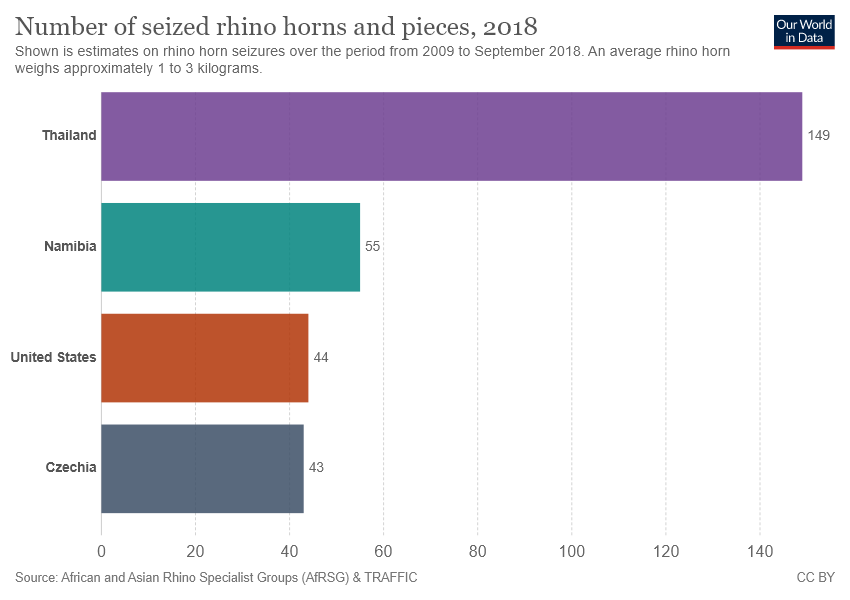Draw attention to some important aspects in this diagram. The value of Namibia and the US are different by 10.. What significance does the United States show in the chart? 44... 